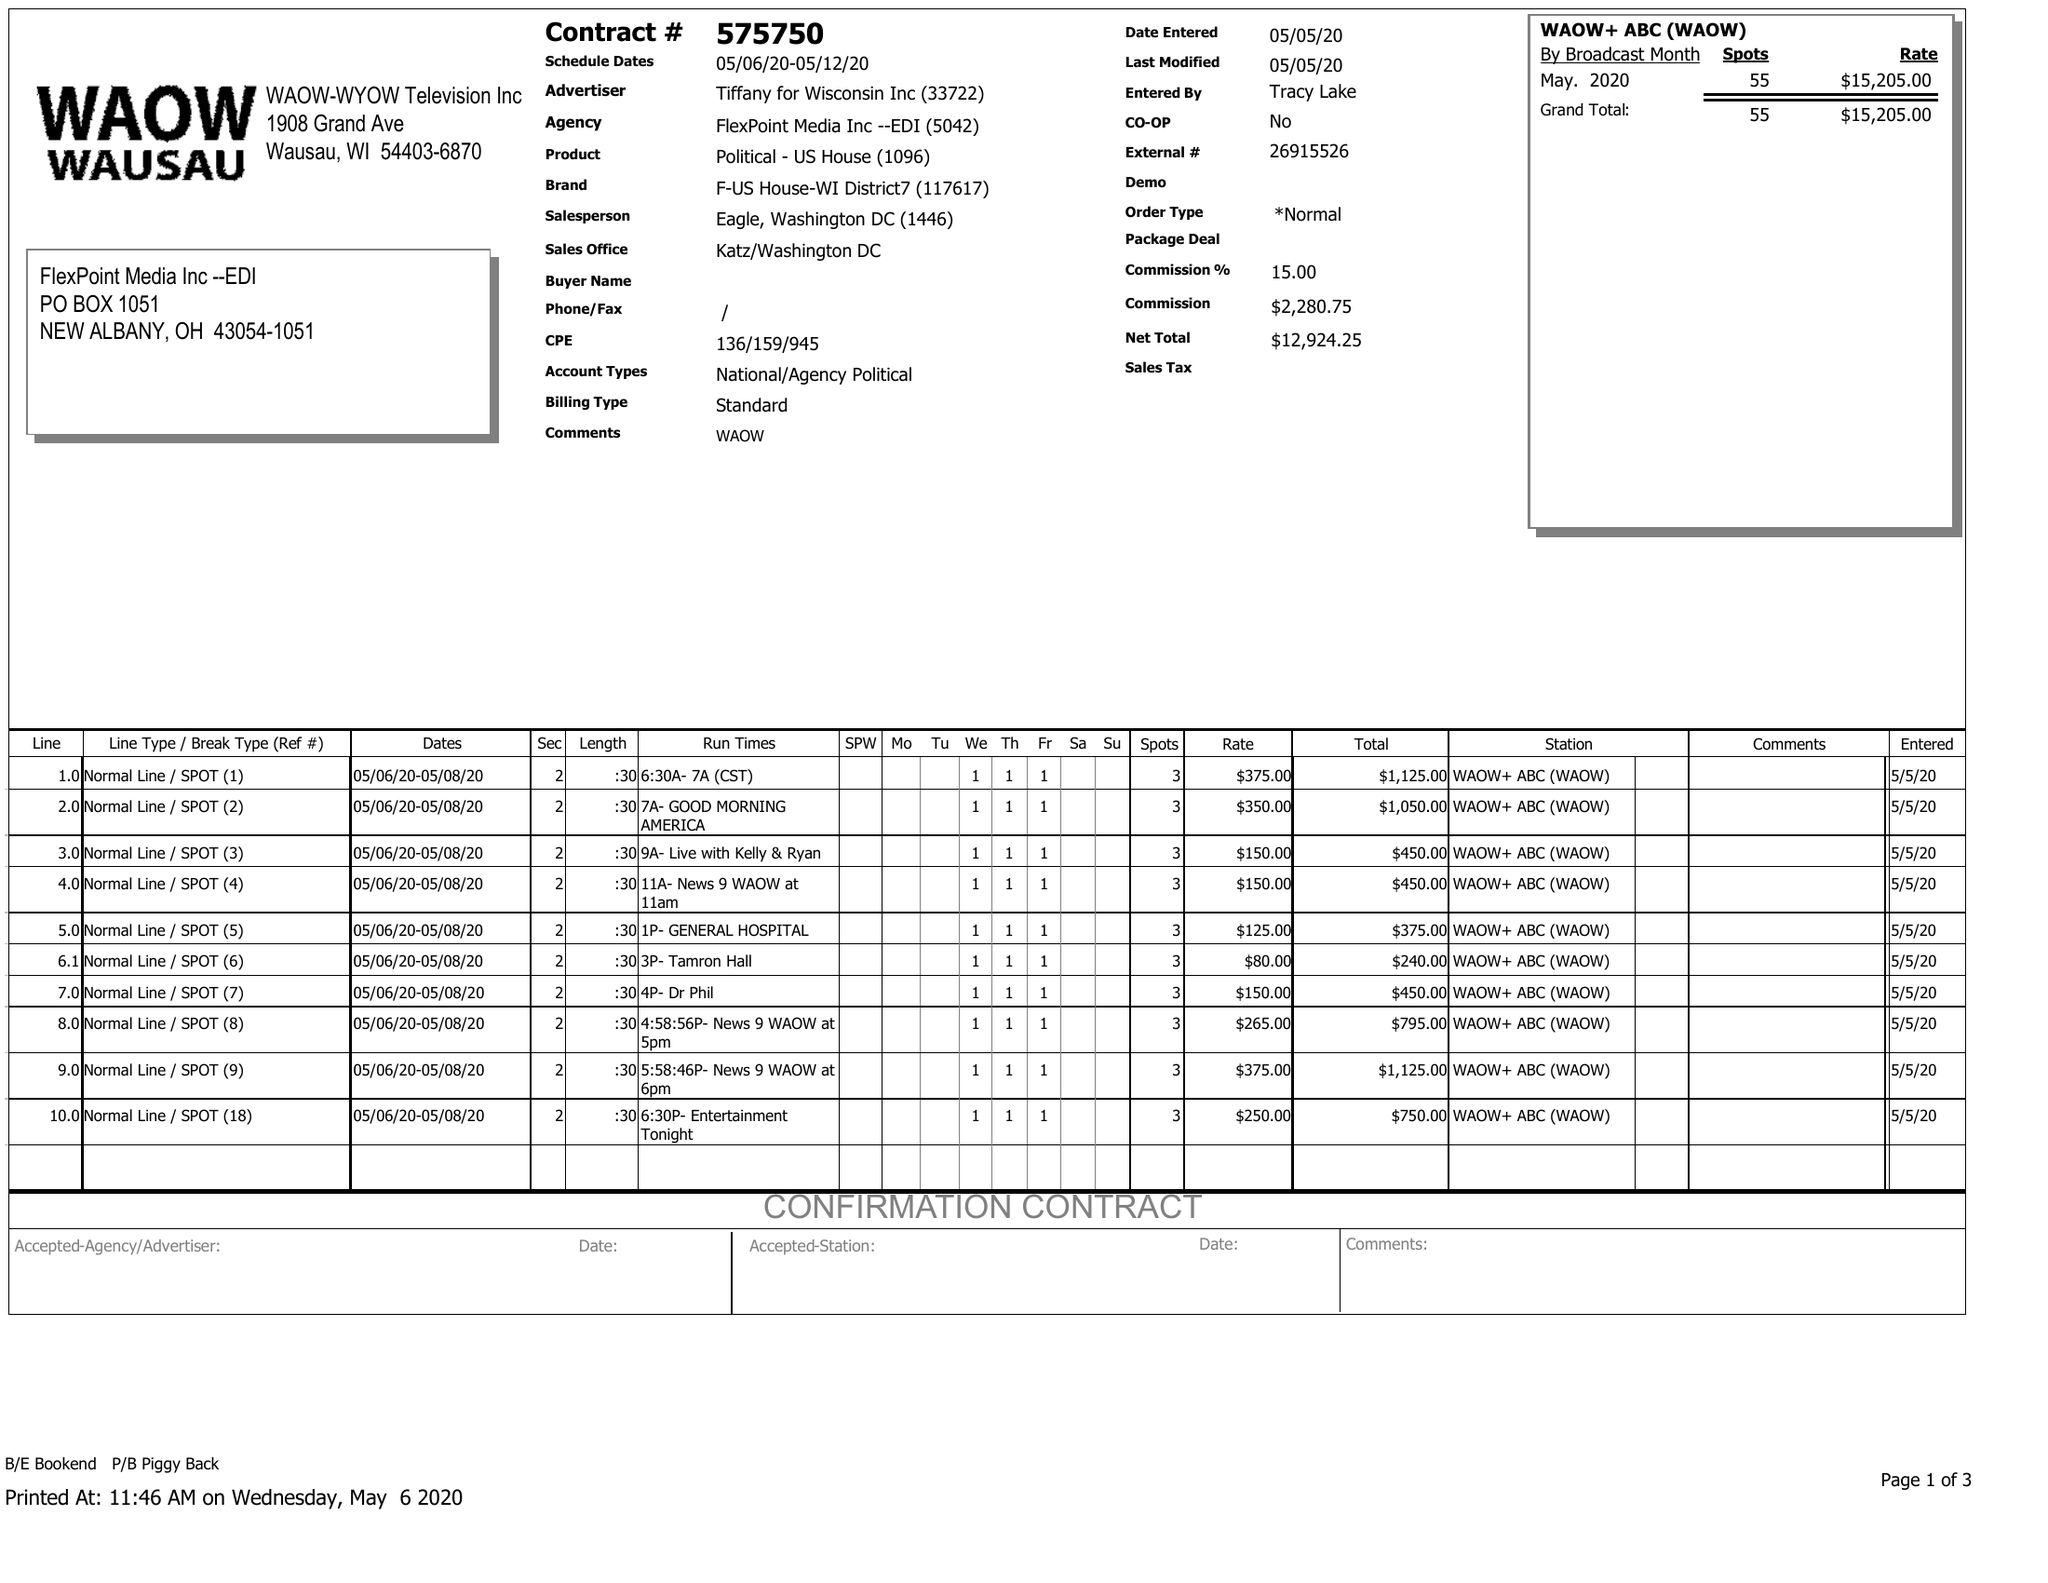What is the value for the flight_to?
Answer the question using a single word or phrase. 05/12/20 